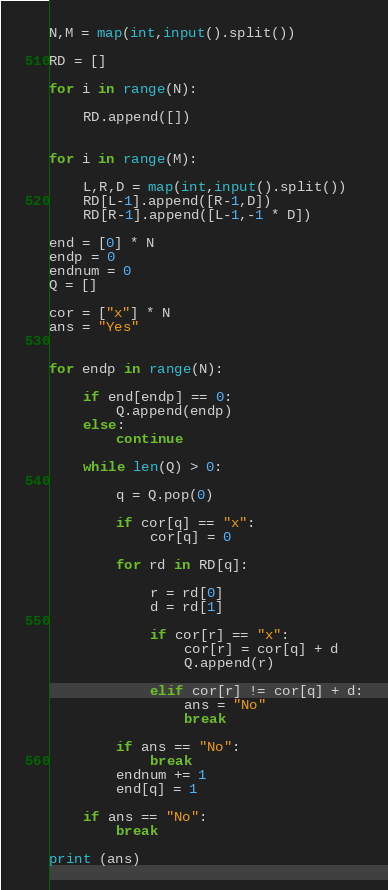Convert code to text. <code><loc_0><loc_0><loc_500><loc_500><_Python_>
N,M = map(int,input().split())

RD = []

for i in range(N):

    RD.append([])


for i in range(M):

    L,R,D = map(int,input().split())
    RD[L-1].append([R-1,D])
    RD[R-1].append([L-1,-1 * D])

end = [0] * N
endp = 0
endnum = 0
Q = []

cor = ["x"] * N
ans = "Yes"


for endp in range(N):

    if end[endp] == 0:
        Q.append(endp)
    else:
        continue

    while len(Q) > 0:

        q = Q.pop(0)

        if cor[q] == "x":
            cor[q] = 0

        for rd in RD[q]:

            r = rd[0]
            d = rd[1]

            if cor[r] == "x":
                cor[r] = cor[q] + d
                Q.append(r)

            elif cor[r] != cor[q] + d:
                ans = "No"
                break

        if ans == "No":
            break
        endnum += 1
        end[q] = 1

    if ans == "No":
        break

print (ans)
</code> 